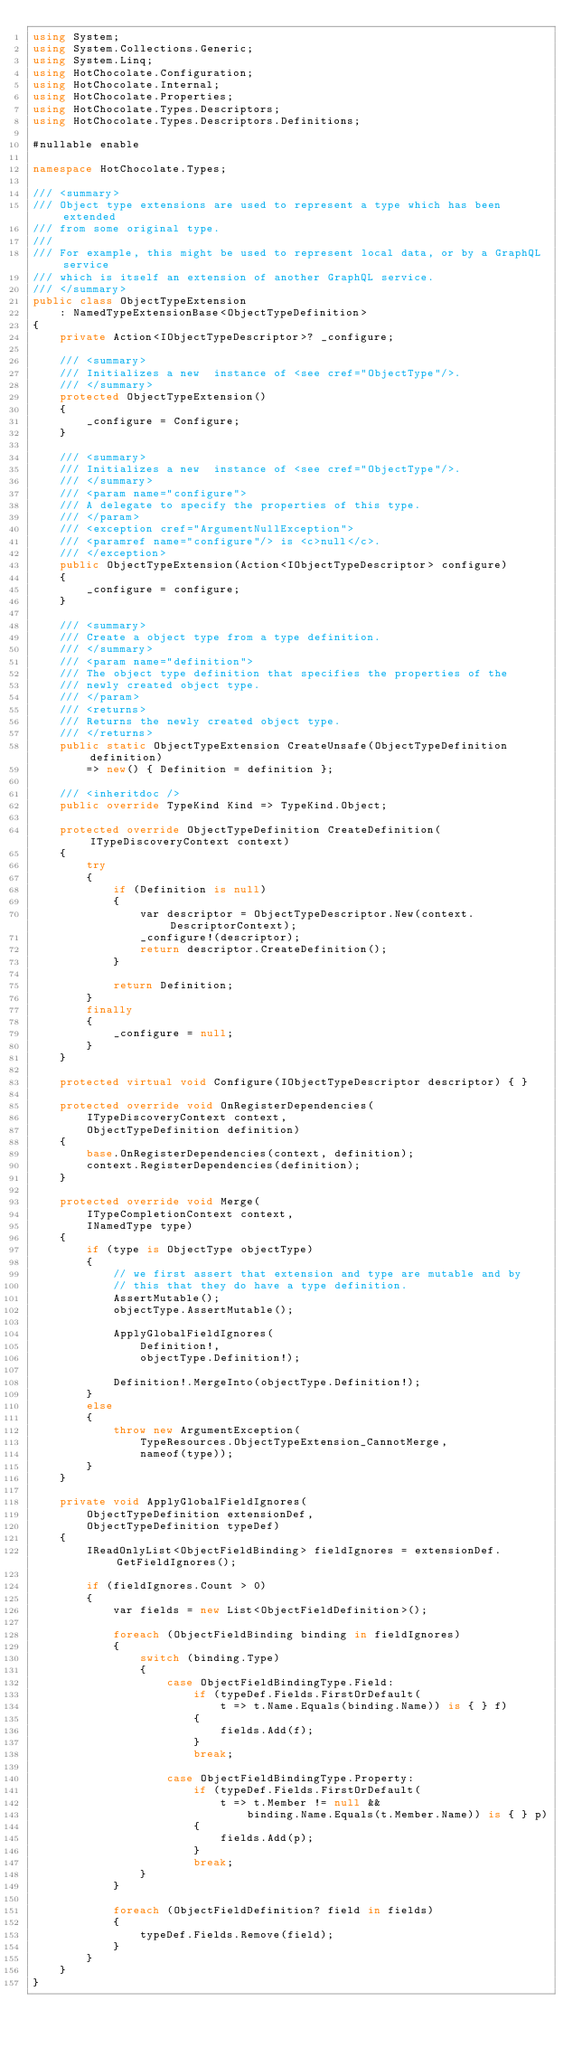Convert code to text. <code><loc_0><loc_0><loc_500><loc_500><_C#_>using System;
using System.Collections.Generic;
using System.Linq;
using HotChocolate.Configuration;
using HotChocolate.Internal;
using HotChocolate.Properties;
using HotChocolate.Types.Descriptors;
using HotChocolate.Types.Descriptors.Definitions;

#nullable enable

namespace HotChocolate.Types;

/// <summary>
/// Object type extensions are used to represent a type which has been extended
/// from some original type.
///
/// For example, this might be used to represent local data, or by a GraphQL service
/// which is itself an extension of another GraphQL service.
/// </summary>
public class ObjectTypeExtension
    : NamedTypeExtensionBase<ObjectTypeDefinition>
{
    private Action<IObjectTypeDescriptor>? _configure;

    /// <summary>
    /// Initializes a new  instance of <see cref="ObjectType"/>.
    /// </summary>
    protected ObjectTypeExtension()
    {
        _configure = Configure;
    }

    /// <summary>
    /// Initializes a new  instance of <see cref="ObjectType"/>.
    /// </summary>
    /// <param name="configure">
    /// A delegate to specify the properties of this type.
    /// </param>
    /// <exception cref="ArgumentNullException">
    /// <paramref name="configure"/> is <c>null</c>.
    /// </exception>
    public ObjectTypeExtension(Action<IObjectTypeDescriptor> configure)
    {
        _configure = configure;
    }

    /// <summary>
    /// Create a object type from a type definition.
    /// </summary>
    /// <param name="definition">
    /// The object type definition that specifies the properties of the
    /// newly created object type.
    /// </param>
    /// <returns>
    /// Returns the newly created object type.
    /// </returns>
    public static ObjectTypeExtension CreateUnsafe(ObjectTypeDefinition definition)
        => new() { Definition = definition };

    /// <inheritdoc />
    public override TypeKind Kind => TypeKind.Object;

    protected override ObjectTypeDefinition CreateDefinition(ITypeDiscoveryContext context)
    {
        try
        {
            if (Definition is null)
            {
                var descriptor = ObjectTypeDescriptor.New(context.DescriptorContext);
                _configure!(descriptor);
                return descriptor.CreateDefinition();
            }

            return Definition;
        }
        finally
        {
            _configure = null;
        }
    }

    protected virtual void Configure(IObjectTypeDescriptor descriptor) { }

    protected override void OnRegisterDependencies(
        ITypeDiscoveryContext context,
        ObjectTypeDefinition definition)
    {
        base.OnRegisterDependencies(context, definition);
        context.RegisterDependencies(definition);
    }

    protected override void Merge(
        ITypeCompletionContext context,
        INamedType type)
    {
        if (type is ObjectType objectType)
        {
            // we first assert that extension and type are mutable and by
            // this that they do have a type definition.
            AssertMutable();
            objectType.AssertMutable();

            ApplyGlobalFieldIgnores(
                Definition!,
                objectType.Definition!);

            Definition!.MergeInto(objectType.Definition!);
        }
        else
        {
            throw new ArgumentException(
                TypeResources.ObjectTypeExtension_CannotMerge,
                nameof(type));
        }
    }

    private void ApplyGlobalFieldIgnores(
        ObjectTypeDefinition extensionDef,
        ObjectTypeDefinition typeDef)
    {
        IReadOnlyList<ObjectFieldBinding> fieldIgnores = extensionDef.GetFieldIgnores();

        if (fieldIgnores.Count > 0)
        {
            var fields = new List<ObjectFieldDefinition>();

            foreach (ObjectFieldBinding binding in fieldIgnores)
            {
                switch (binding.Type)
                {
                    case ObjectFieldBindingType.Field:
                        if (typeDef.Fields.FirstOrDefault(
                            t => t.Name.Equals(binding.Name)) is { } f)
                        {
                            fields.Add(f);
                        }
                        break;

                    case ObjectFieldBindingType.Property:
                        if (typeDef.Fields.FirstOrDefault(
                            t => t.Member != null &&
                                binding.Name.Equals(t.Member.Name)) is { } p)
                        {
                            fields.Add(p);
                        }
                        break;
                }
            }

            foreach (ObjectFieldDefinition? field in fields)
            {
                typeDef.Fields.Remove(field);
            }
        }
    }
}
</code> 